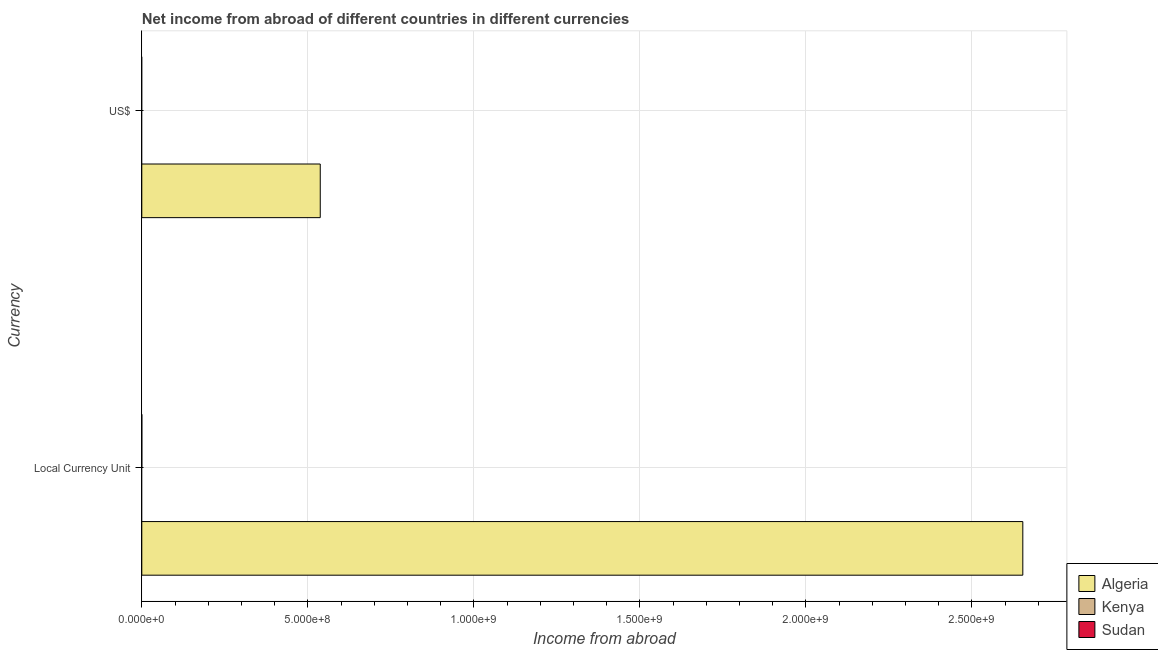How many different coloured bars are there?
Your response must be concise. 1. Are the number of bars per tick equal to the number of legend labels?
Ensure brevity in your answer.  No. What is the label of the 1st group of bars from the top?
Keep it short and to the point. US$. What is the income from abroad in constant 2005 us$ in Algeria?
Provide a succinct answer. 2.65e+09. Across all countries, what is the maximum income from abroad in us$?
Your response must be concise. 5.37e+08. In which country was the income from abroad in constant 2005 us$ maximum?
Make the answer very short. Algeria. What is the total income from abroad in constant 2005 us$ in the graph?
Keep it short and to the point. 2.65e+09. What is the difference between the income from abroad in us$ in Kenya and the income from abroad in constant 2005 us$ in Algeria?
Provide a succinct answer. -2.65e+09. What is the average income from abroad in us$ per country?
Provide a succinct answer. 1.79e+08. What is the difference between the income from abroad in us$ and income from abroad in constant 2005 us$ in Algeria?
Provide a succinct answer. -2.12e+09. In how many countries, is the income from abroad in constant 2005 us$ greater than the average income from abroad in constant 2005 us$ taken over all countries?
Your answer should be compact. 1. Are all the bars in the graph horizontal?
Keep it short and to the point. Yes. How many countries are there in the graph?
Your answer should be compact. 3. Where does the legend appear in the graph?
Your response must be concise. Bottom right. How are the legend labels stacked?
Offer a very short reply. Vertical. What is the title of the graph?
Your answer should be very brief. Net income from abroad of different countries in different currencies. What is the label or title of the X-axis?
Offer a terse response. Income from abroad. What is the label or title of the Y-axis?
Your answer should be compact. Currency. What is the Income from abroad of Algeria in Local Currency Unit?
Your answer should be very brief. 2.65e+09. What is the Income from abroad of Kenya in Local Currency Unit?
Make the answer very short. 0. What is the Income from abroad of Algeria in US$?
Your answer should be compact. 5.37e+08. Across all Currency, what is the maximum Income from abroad of Algeria?
Make the answer very short. 2.65e+09. Across all Currency, what is the minimum Income from abroad in Algeria?
Offer a terse response. 5.37e+08. What is the total Income from abroad of Algeria in the graph?
Your response must be concise. 3.19e+09. What is the total Income from abroad of Kenya in the graph?
Make the answer very short. 0. What is the difference between the Income from abroad in Algeria in Local Currency Unit and that in US$?
Your answer should be very brief. 2.12e+09. What is the average Income from abroad of Algeria per Currency?
Your answer should be very brief. 1.60e+09. What is the average Income from abroad in Kenya per Currency?
Give a very brief answer. 0. What is the ratio of the Income from abroad in Algeria in Local Currency Unit to that in US$?
Your response must be concise. 4.94. What is the difference between the highest and the second highest Income from abroad in Algeria?
Make the answer very short. 2.12e+09. What is the difference between the highest and the lowest Income from abroad in Algeria?
Provide a short and direct response. 2.12e+09. 